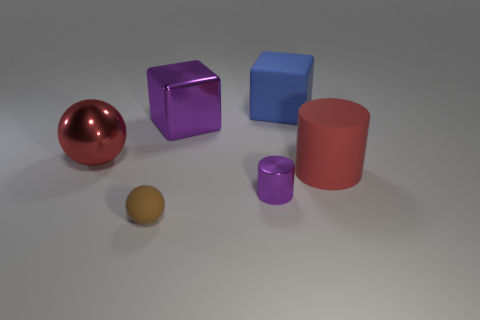Add 3 brown shiny blocks. How many objects exist? 9 Subtract all blocks. How many objects are left? 4 Add 6 big metal spheres. How many big metal spheres are left? 7 Add 3 yellow matte cubes. How many yellow matte cubes exist? 3 Subtract 1 purple cylinders. How many objects are left? 5 Subtract all cyan cylinders. Subtract all cyan blocks. How many cylinders are left? 2 Subtract all big red metal objects. Subtract all purple cubes. How many objects are left? 4 